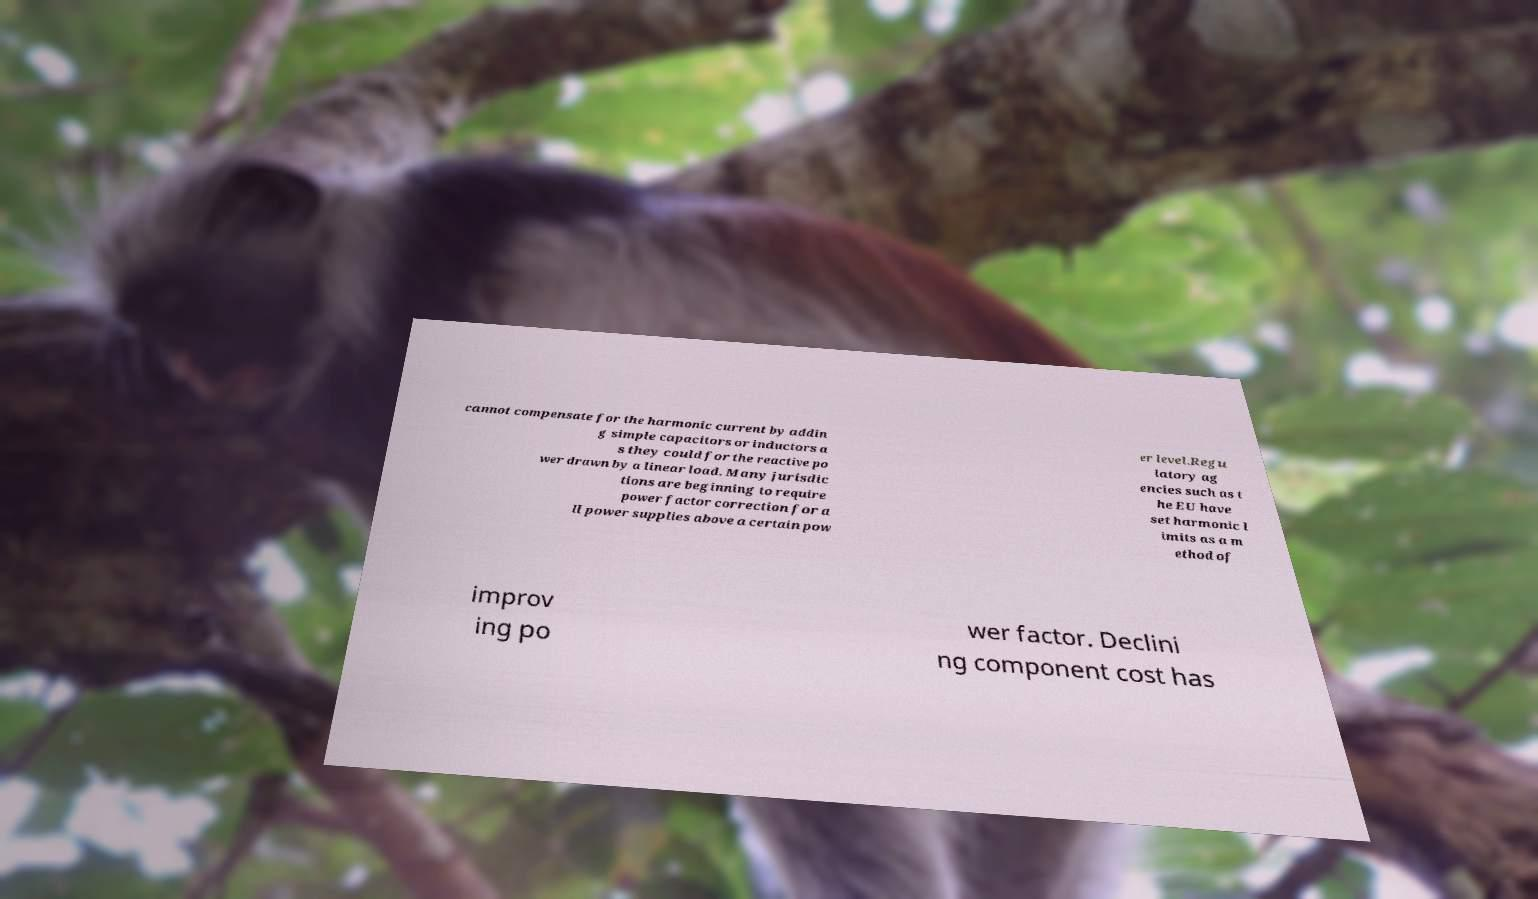Could you extract and type out the text from this image? cannot compensate for the harmonic current by addin g simple capacitors or inductors a s they could for the reactive po wer drawn by a linear load. Many jurisdic tions are beginning to require power factor correction for a ll power supplies above a certain pow er level.Regu latory ag encies such as t he EU have set harmonic l imits as a m ethod of improv ing po wer factor. Declini ng component cost has 